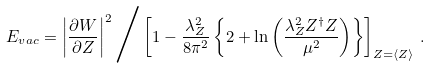<formula> <loc_0><loc_0><loc_500><loc_500>E _ { v a c } = \left | \frac { \partial W } { \partial Z } \right | ^ { 2 } \Big / \left [ 1 - \frac { \lambda ^ { 2 } _ { Z } } { 8 \pi ^ { 2 } } \left \{ 2 + \ln \left ( \frac { \lambda _ { Z } ^ { 2 } Z ^ { \dagger } Z } { \mu ^ { 2 } } \right ) \right \} \right ] _ { Z = \langle Z \rangle } \, .</formula> 